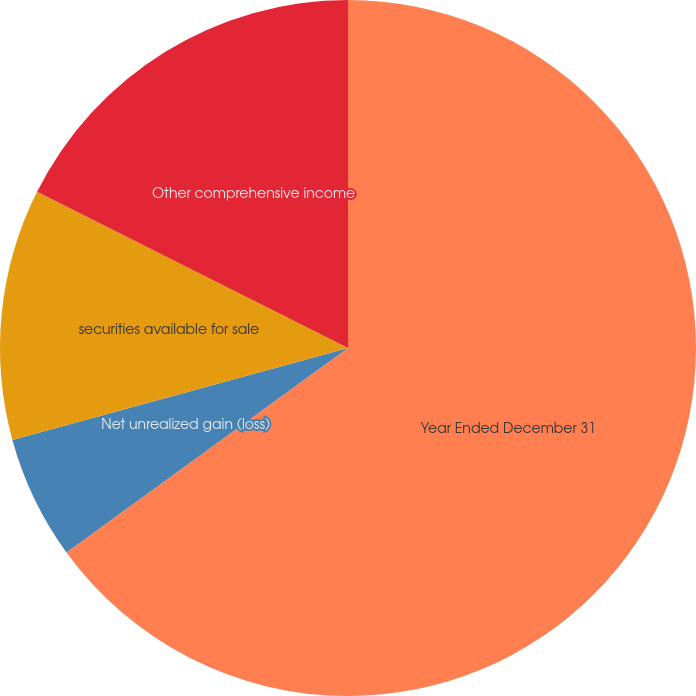<chart> <loc_0><loc_0><loc_500><loc_500><pie_chart><fcel>Year Ended December 31<fcel>Net unrealized gain (loss)<fcel>securities available for sale<fcel>Other comprehensive income<nl><fcel>65.0%<fcel>5.74%<fcel>11.67%<fcel>17.59%<nl></chart> 